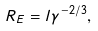<formula> <loc_0><loc_0><loc_500><loc_500>R _ { E } = l \gamma ^ { - 2 / 3 } ,</formula> 